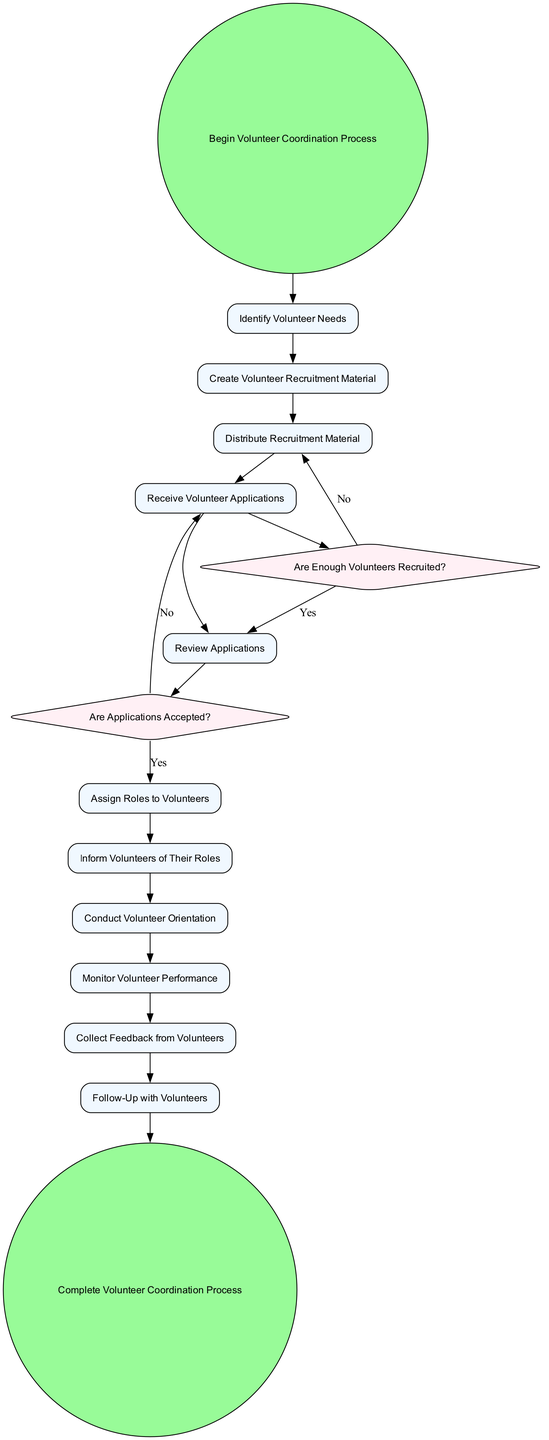What is the starting point of the diagram? The starting point is indicated by the 'Begin Volunteer Coordination Process' node, which initiates the sequence of actions.
Answer: Begin Volunteer Coordination Process How many actions are identified in the diagram? There are 11 actions listed in the diagram, each representing a step in the volunteer coordination process.
Answer: 11 What action follows the decision point 'Are Enough Volunteers Recruited?' if the answer is 'Yes'? If the answer is 'Yes', the next action is 'Review Applications', continuing the flow of the process for volunteer coordination.
Answer: Review Applications What is the final action in the volunteer coordination process? The final action is 'Follow-Up with Volunteers', which comes before reaching the end of the process.
Answer: Follow-Up with Volunteers Which decision point evaluates the suitability of volunteer applications? The decision point that evaluates the suitability of volunteer applications is 'Are Applications Accepted?'.
Answer: Are Applications Accepted? What happens if not enough volunteers are recruited? If not enough volunteers are recruited, the process loops back to 'Distribute Recruitment Material', allowing for further recruitment efforts.
Answer: Distribute Recruitment Material What is the purpose of the 'Conduct Volunteer Orientation' action? The purpose of this action is to inform volunteers about their responsibilities and provide details about the event, ensuring they are prepared.
Answer: Inform volunteers about their responsibilities What is the significance of the 'Complete Volunteer Coordination Process' event? This end event signifies the finalization of all activities related to volunteer coordination after the event, marking the conclusion of the process.
Answer: Complete Volunteer Coordination Process 